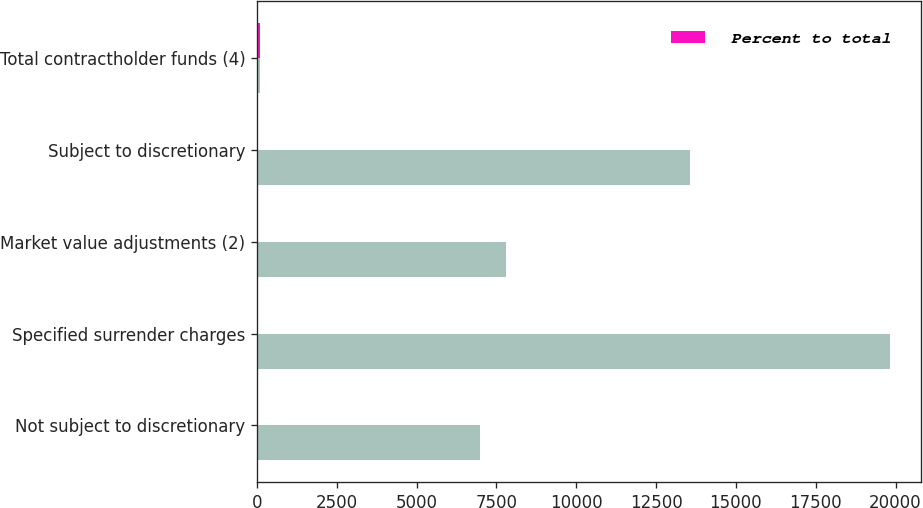Convert chart to OTSL. <chart><loc_0><loc_0><loc_500><loc_500><stacked_bar_chart><ecel><fcel>Not subject to discretionary<fcel>Specified surrender charges<fcel>Market value adjustments (2)<fcel>Subject to discretionary<fcel>Total contractholder funds (4)<nl><fcel>nan<fcel>6998<fcel>19815<fcel>7805<fcel>13577<fcel>100<nl><fcel>Percent to total<fcel>14.5<fcel>41.1<fcel>16.2<fcel>28.2<fcel>100<nl></chart> 